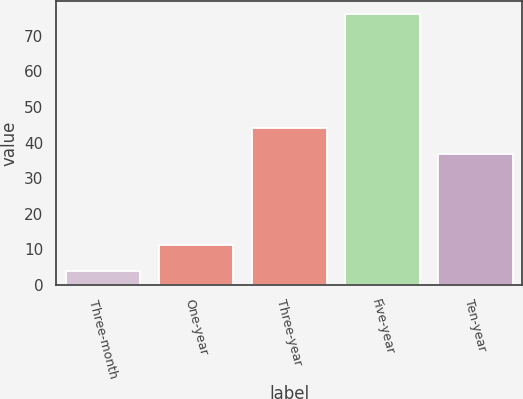<chart> <loc_0><loc_0><loc_500><loc_500><bar_chart><fcel>Three-month<fcel>One-year<fcel>Three-year<fcel>Five-year<fcel>Ten-year<nl><fcel>3.9<fcel>11.11<fcel>44.11<fcel>76<fcel>36.9<nl></chart> 